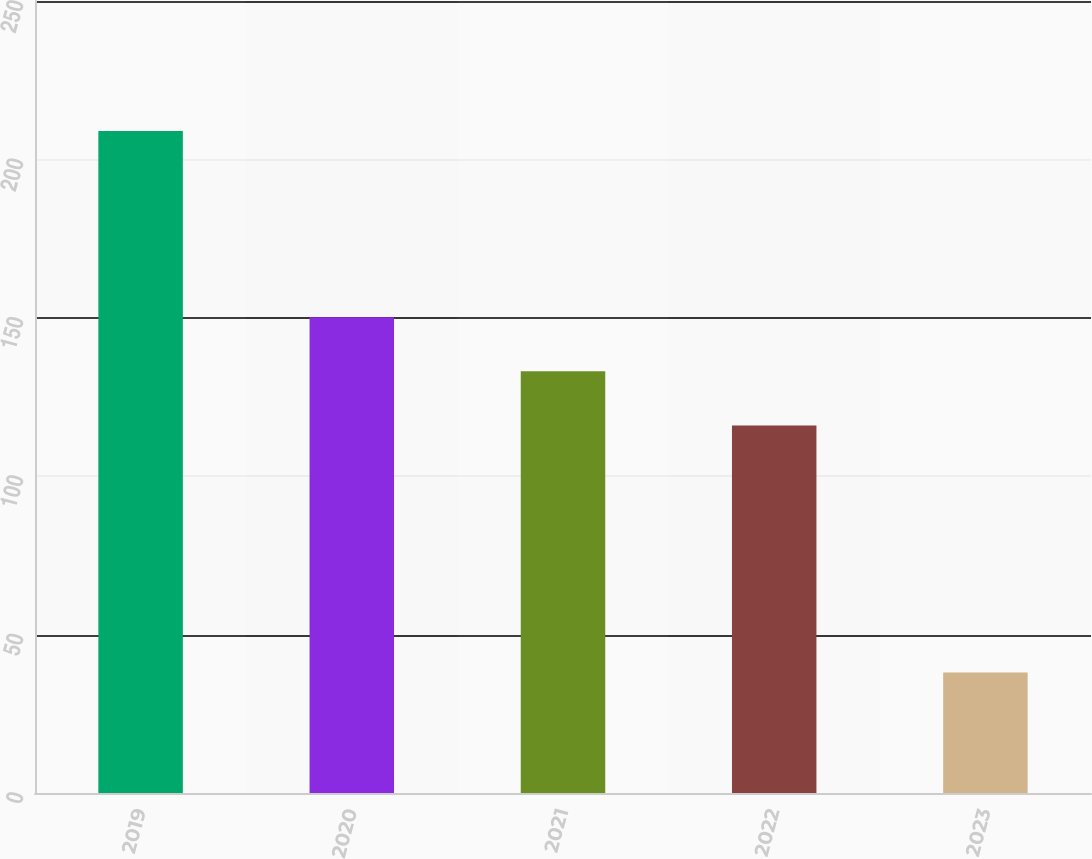Convert chart. <chart><loc_0><loc_0><loc_500><loc_500><bar_chart><fcel>2019<fcel>2020<fcel>2021<fcel>2022<fcel>2023<nl><fcel>209<fcel>150.2<fcel>133.1<fcel>116<fcel>38<nl></chart> 